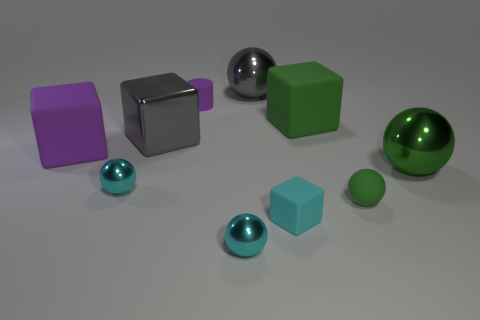The big metal object that is the same shape as the small cyan rubber thing is what color?
Your response must be concise. Gray. What number of metal objects are the same color as the tiny matte cylinder?
Your response must be concise. 0. Is the small block the same color as the tiny cylinder?
Keep it short and to the point. No. How many objects are spheres on the right side of the cylinder or big gray balls?
Your answer should be compact. 4. What is the color of the big rubber block that is to the left of the purple thing that is behind the large matte block in front of the big metallic block?
Give a very brief answer. Purple. What is the color of the small ball that is the same material as the tiny cylinder?
Keep it short and to the point. Green. How many other small balls have the same material as the small green ball?
Make the answer very short. 0. Do the matte thing that is in front of the rubber sphere and the green rubber ball have the same size?
Your response must be concise. Yes. There is a matte ball that is the same size as the purple cylinder; what color is it?
Keep it short and to the point. Green. What number of rubber spheres are on the right side of the big purple thing?
Offer a terse response. 1. 